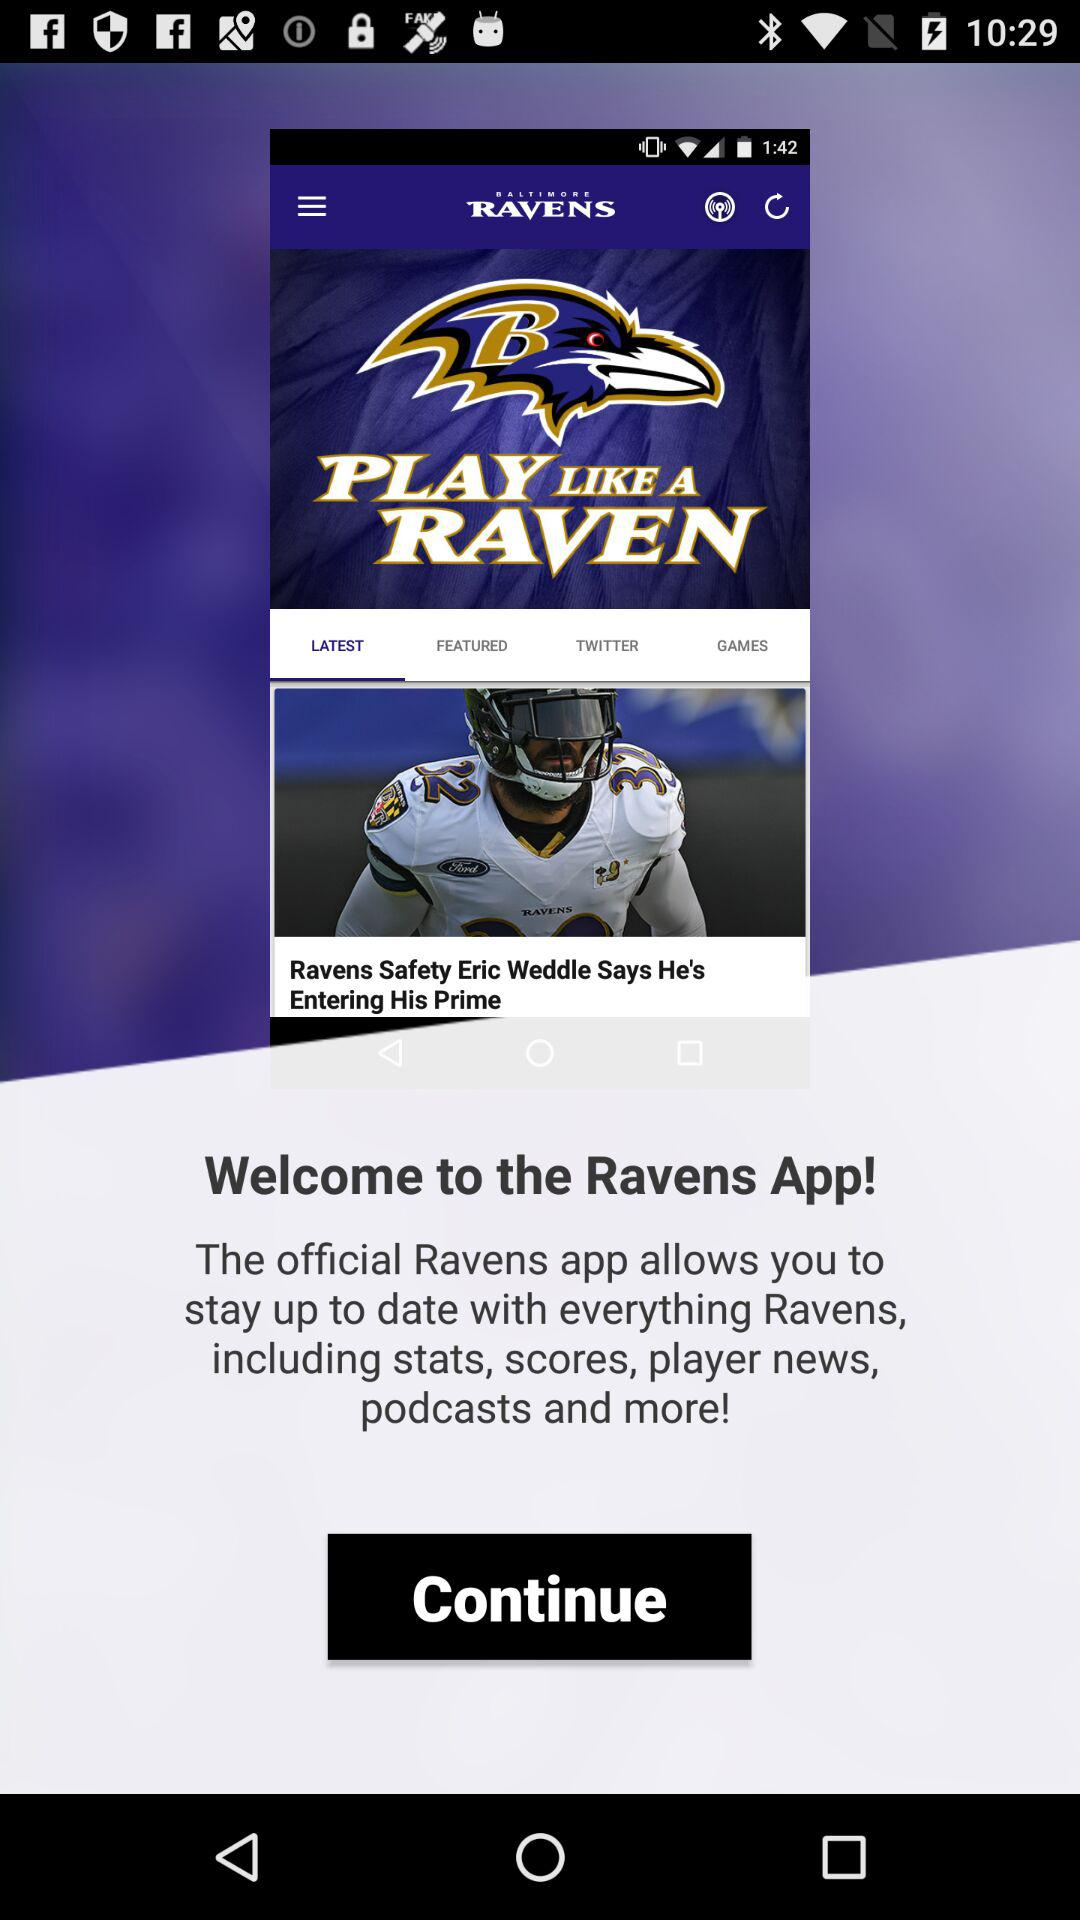Who is the quarterback on the "Ravens"?
When the provided information is insufficient, respond with <no answer>. <no answer> 